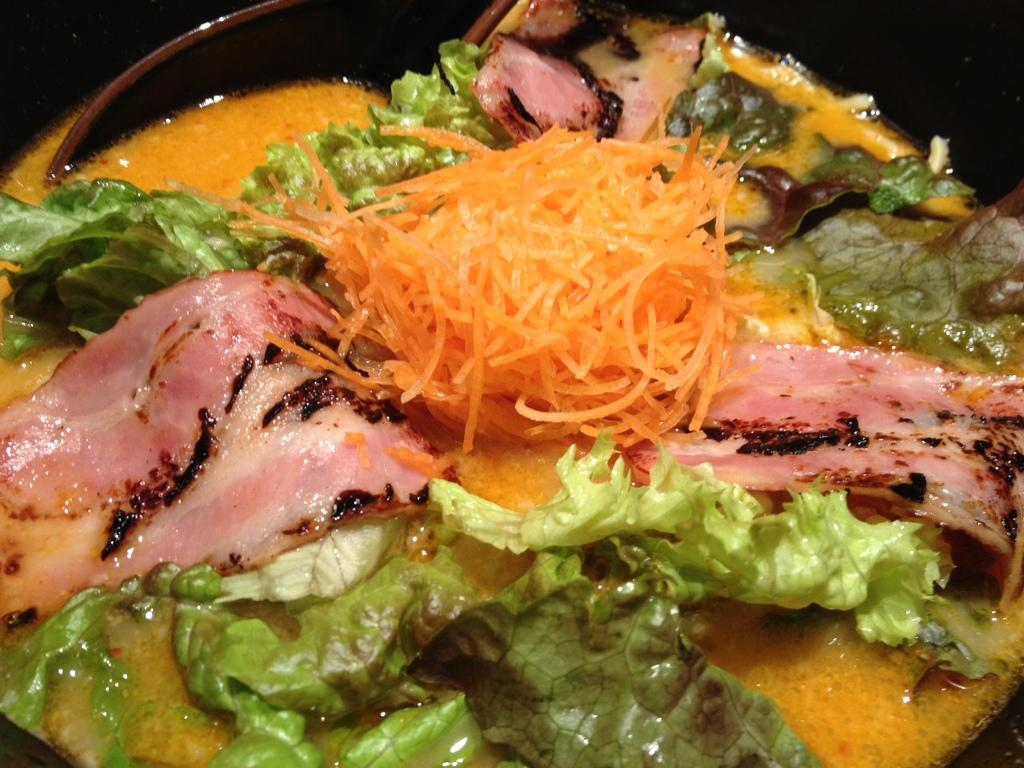What type of objects can be seen in the image? There are food items in the image. What utensil is present in the image? There is a spoon in the image. What type of scene is depicted in the image? The image does not depict a scene; it only shows food items and a spoon. How many rolls can be seen in the image? There are no rolls present in the image. 